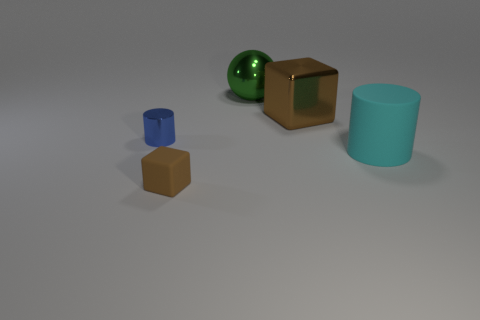Add 5 large brown objects. How many objects exist? 10 Subtract all spheres. How many objects are left? 4 Add 1 small objects. How many small objects are left? 3 Add 2 green balls. How many green balls exist? 3 Subtract 0 gray spheres. How many objects are left? 5 Subtract all large cyan spheres. Subtract all large spheres. How many objects are left? 4 